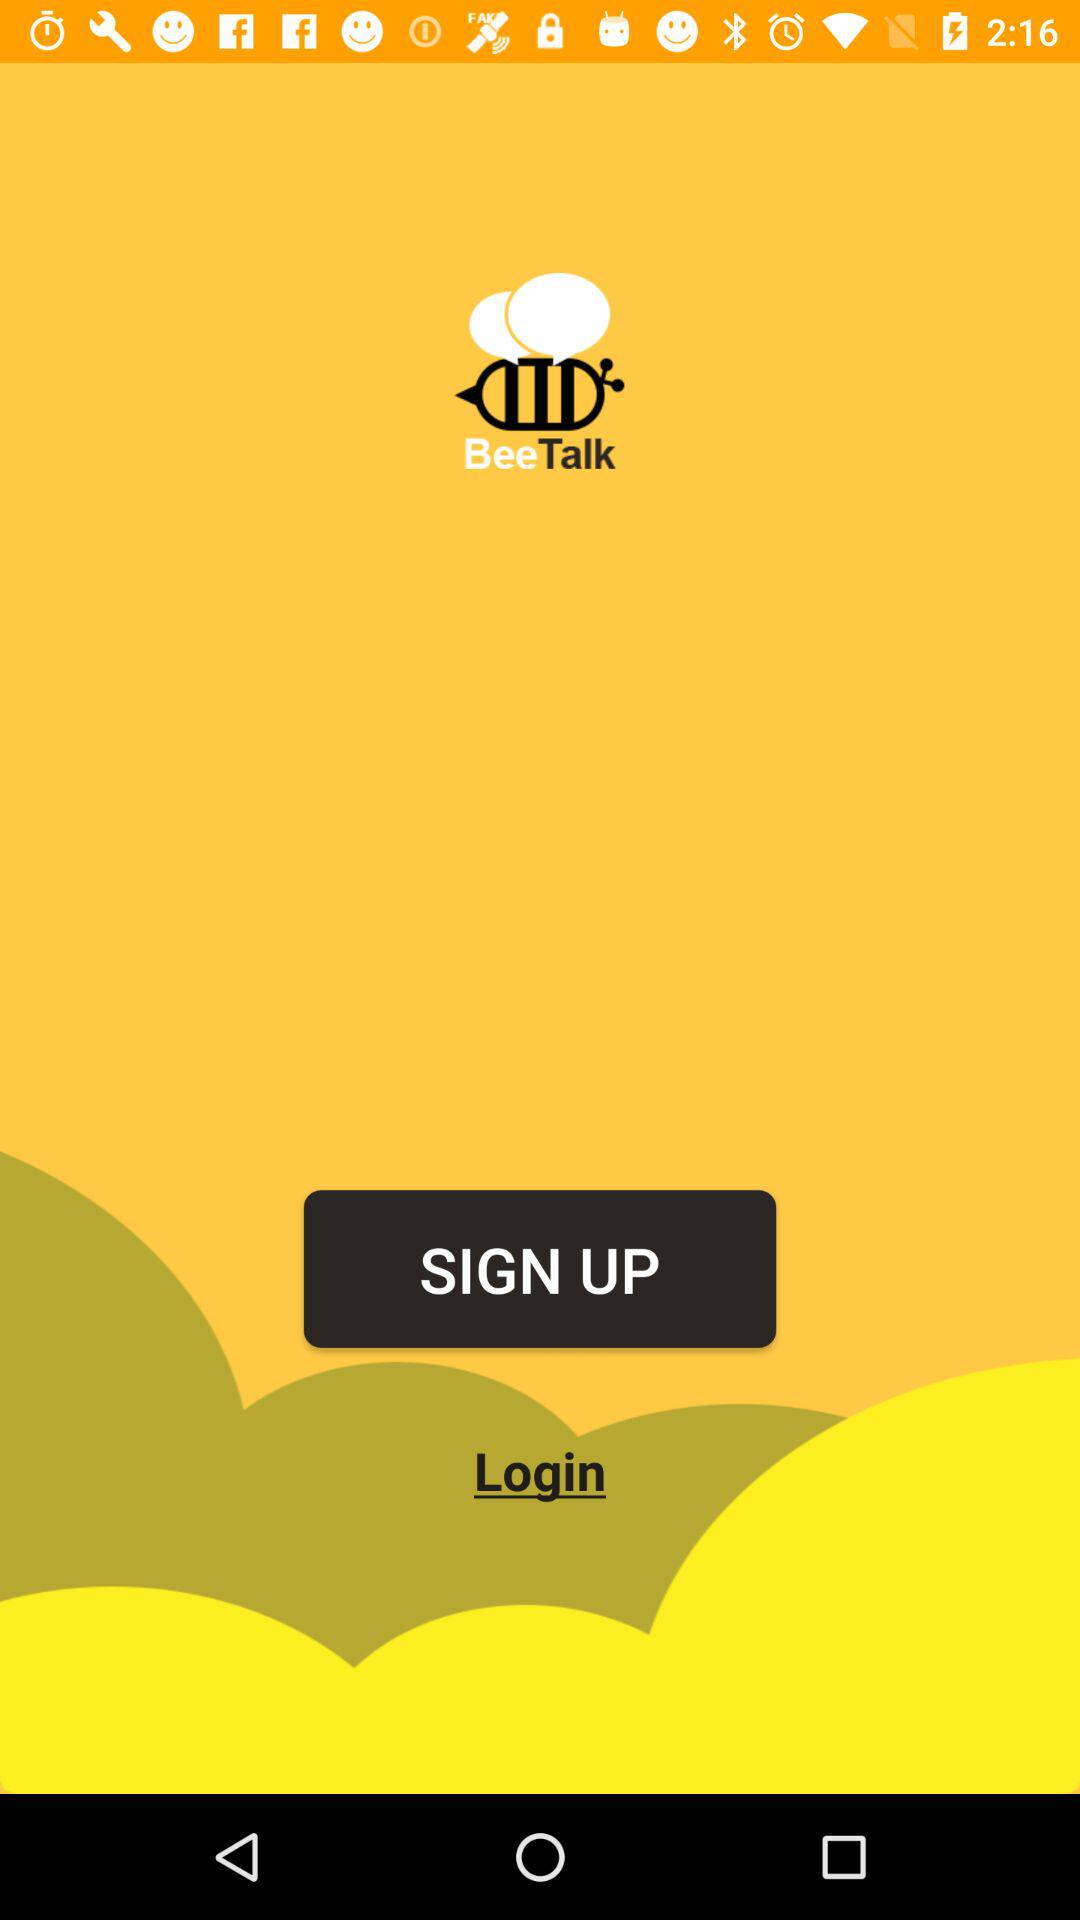What is the name of the application? The name of the application is BeeTalk. 